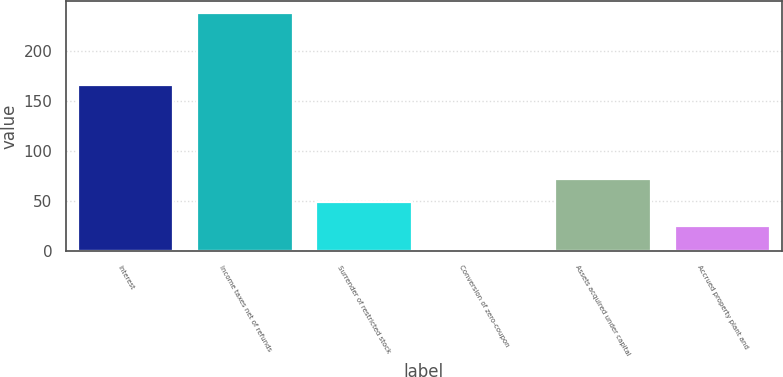Convert chart. <chart><loc_0><loc_0><loc_500><loc_500><bar_chart><fcel>Interest<fcel>Income taxes net of refunds<fcel>Surrender of restricted stock<fcel>Conversion of zero-coupon<fcel>Assets acquired under capital<fcel>Accrued property plant and<nl><fcel>166.1<fcel>237.6<fcel>48.4<fcel>1.1<fcel>72.05<fcel>24.75<nl></chart> 